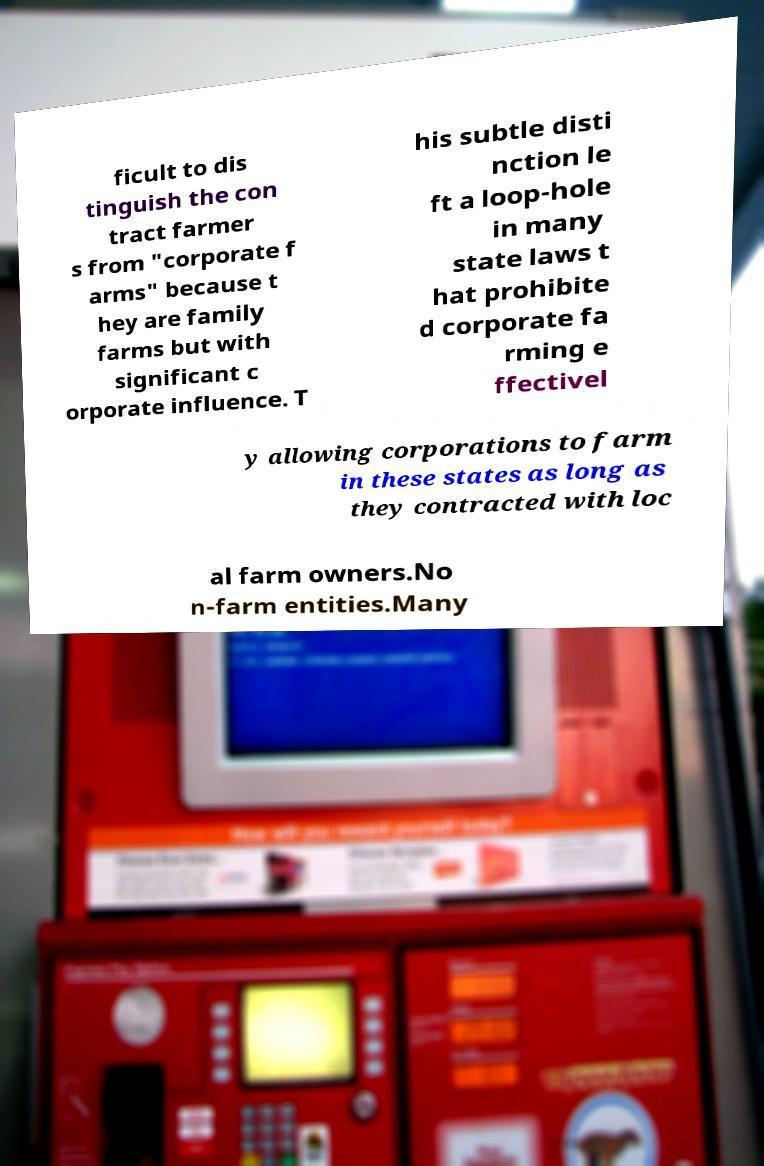Could you assist in decoding the text presented in this image and type it out clearly? ficult to dis tinguish the con tract farmer s from "corporate f arms" because t hey are family farms but with significant c orporate influence. T his subtle disti nction le ft a loop-hole in many state laws t hat prohibite d corporate fa rming e ffectivel y allowing corporations to farm in these states as long as they contracted with loc al farm owners.No n-farm entities.Many 